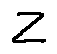Convert formula to latex. <formula><loc_0><loc_0><loc_500><loc_500>z</formula> 